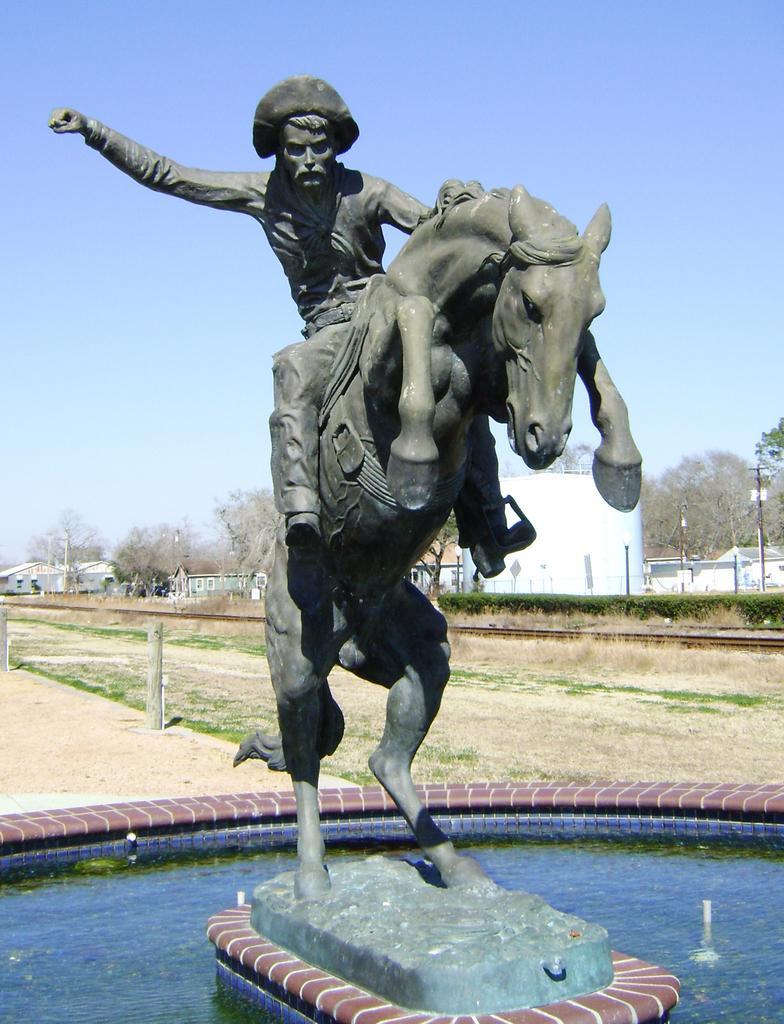Describe this image in one or two sentences. In this image, There is water which is in blue color, In the middle there is a horse statue on that there is a man siting and raising his hand, In the background there is a ground in brown color and there are some trees which are in green color, There is sky which is in blue color. 